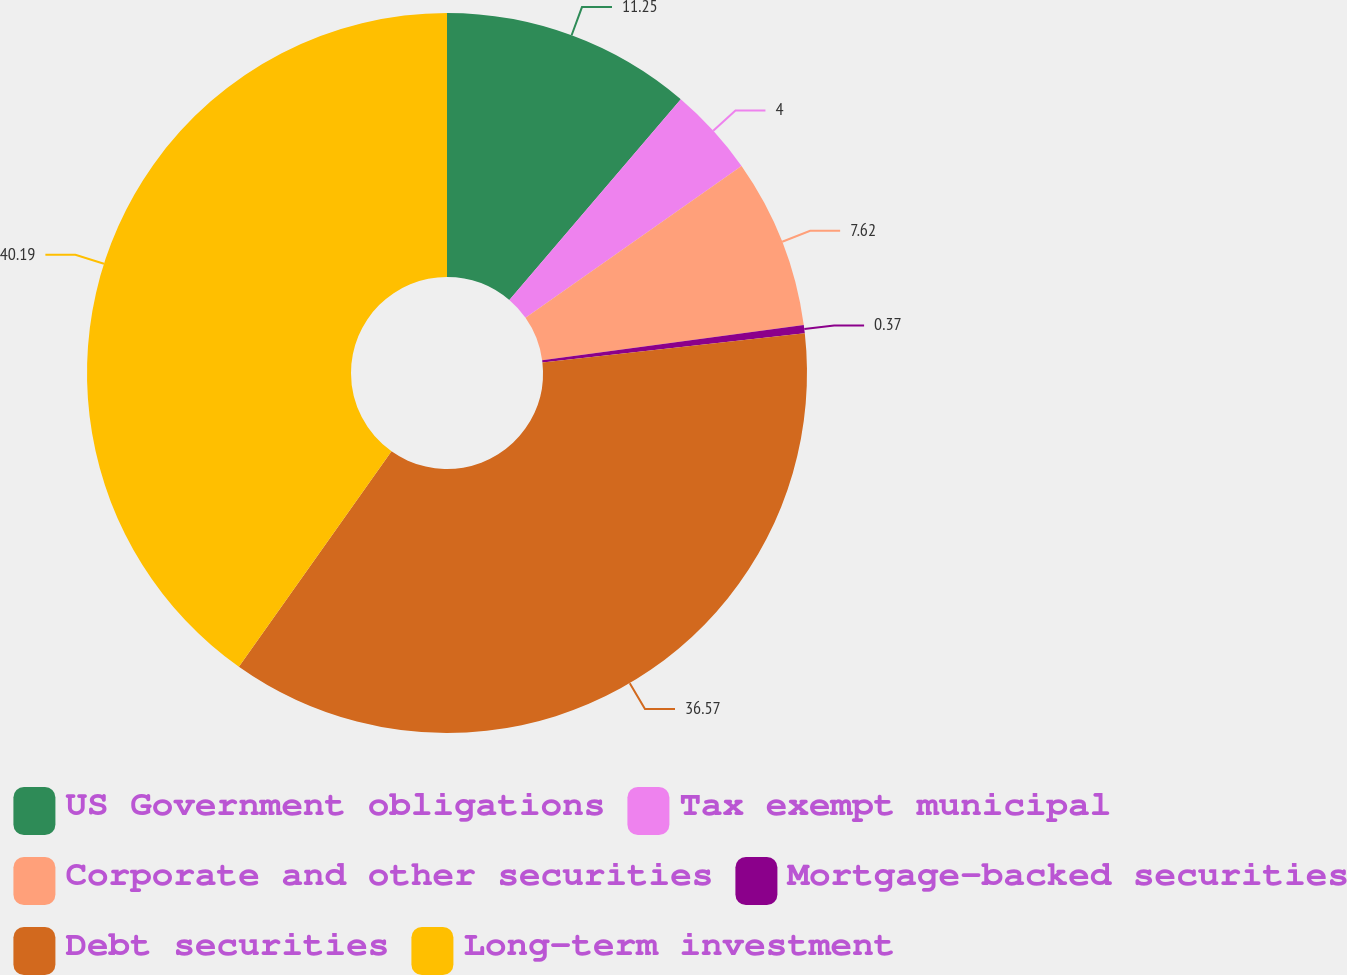Convert chart to OTSL. <chart><loc_0><loc_0><loc_500><loc_500><pie_chart><fcel>US Government obligations<fcel>Tax exempt municipal<fcel>Corporate and other securities<fcel>Mortgage-backed securities<fcel>Debt securities<fcel>Long-term investment<nl><fcel>11.25%<fcel>4.0%<fcel>7.62%<fcel>0.37%<fcel>36.57%<fcel>40.19%<nl></chart> 